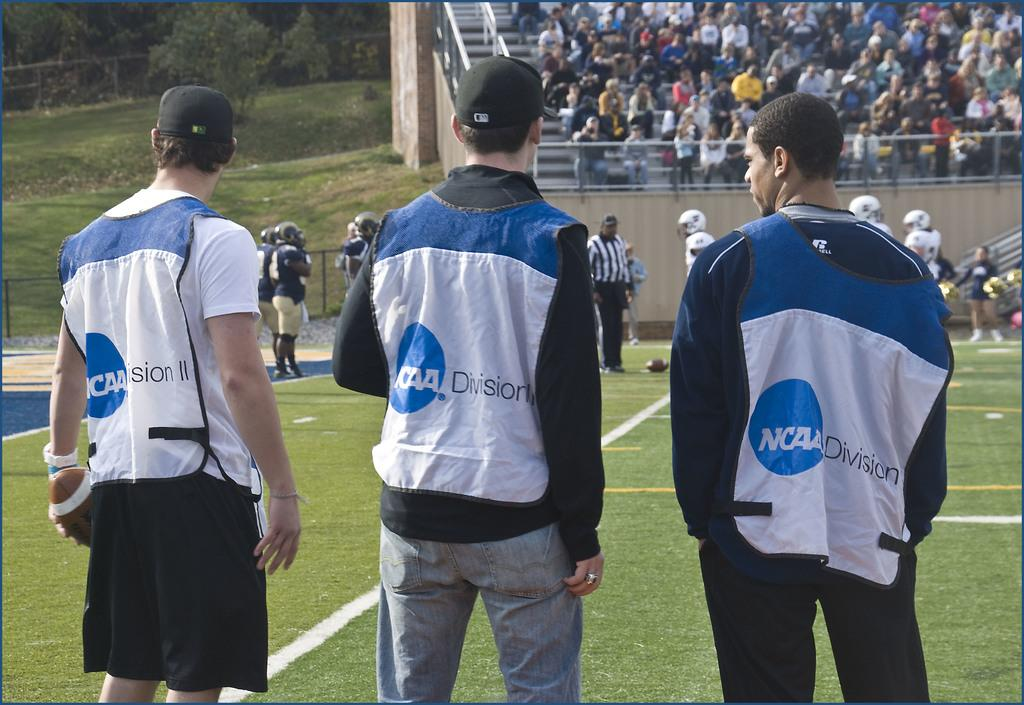<image>
Render a clear and concise summary of the photo. Three men with NCAA division on their clothing stand on a field. 